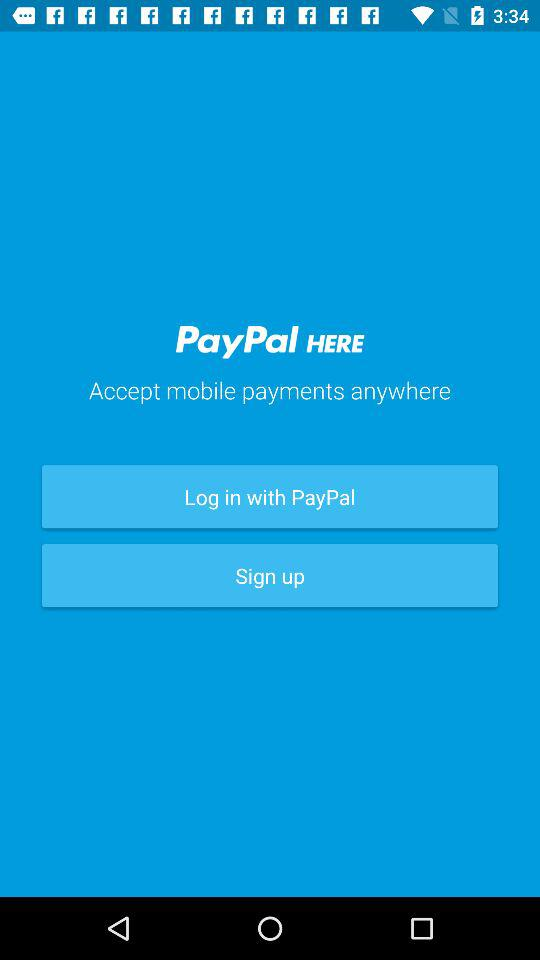What application can be used to log in? The application that can be used to log in is "PayPal". 